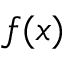Convert formula to latex. <formula><loc_0><loc_0><loc_500><loc_500>f ( x )</formula> 